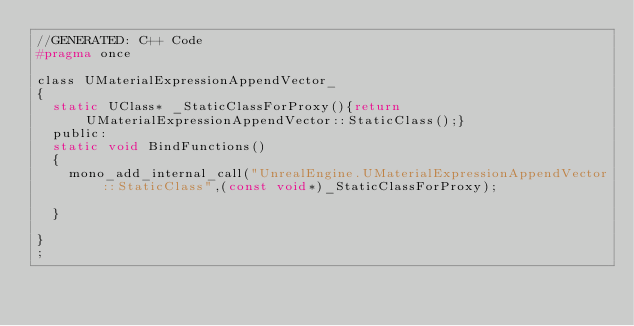Convert code to text. <code><loc_0><loc_0><loc_500><loc_500><_C_>//GENERATED: C++ Code
#pragma once

class UMaterialExpressionAppendVector_
{
	static UClass* _StaticClassForProxy(){return UMaterialExpressionAppendVector::StaticClass();}
	public:
	static void BindFunctions()
	{
		mono_add_internal_call("UnrealEngine.UMaterialExpressionAppendVector::StaticClass",(const void*)_StaticClassForProxy);
		
	}
	
}
;</code> 